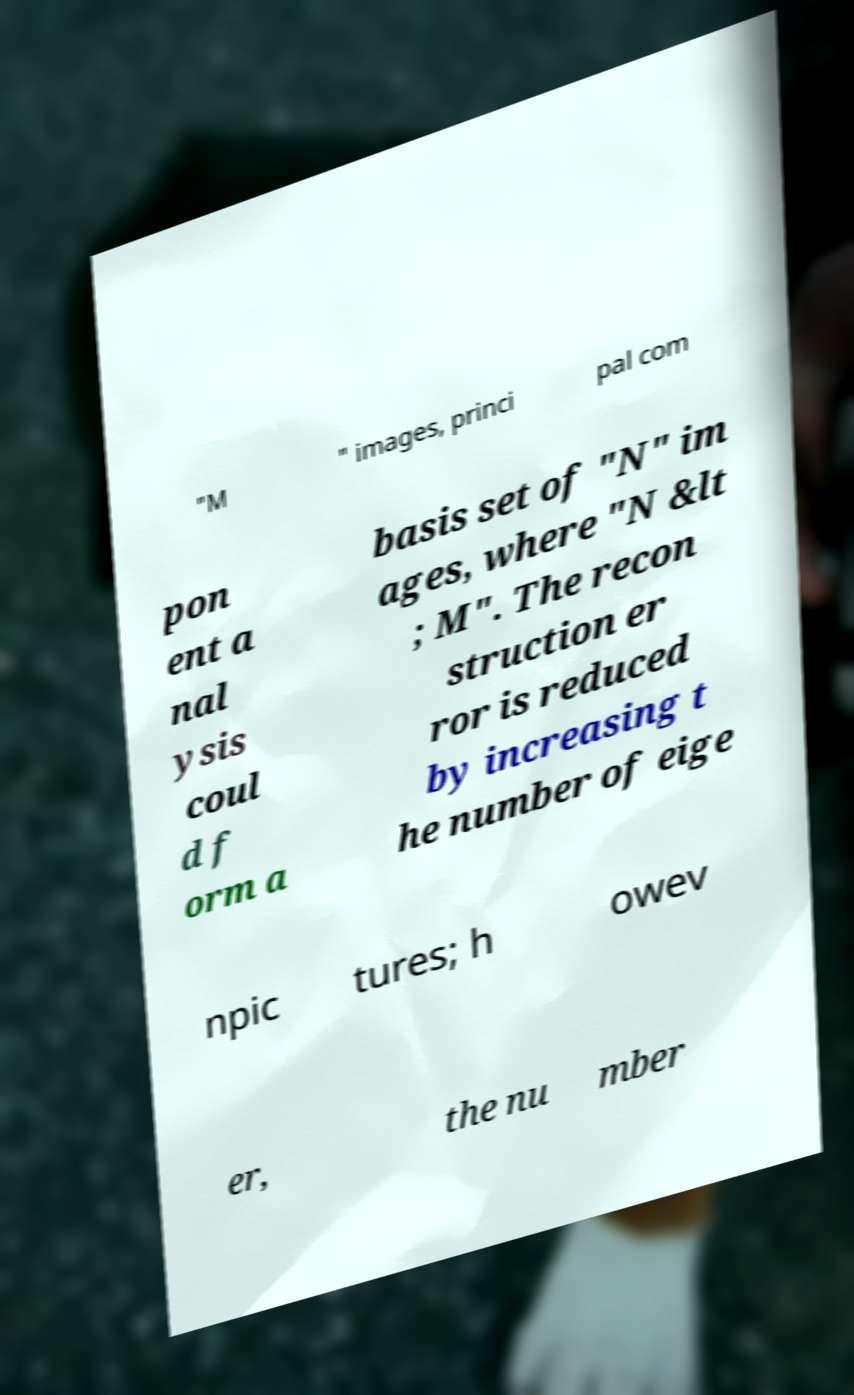For documentation purposes, I need the text within this image transcribed. Could you provide that? "M " images, princi pal com pon ent a nal ysis coul d f orm a basis set of "N" im ages, where "N &lt ; M". The recon struction er ror is reduced by increasing t he number of eige npic tures; h owev er, the nu mber 